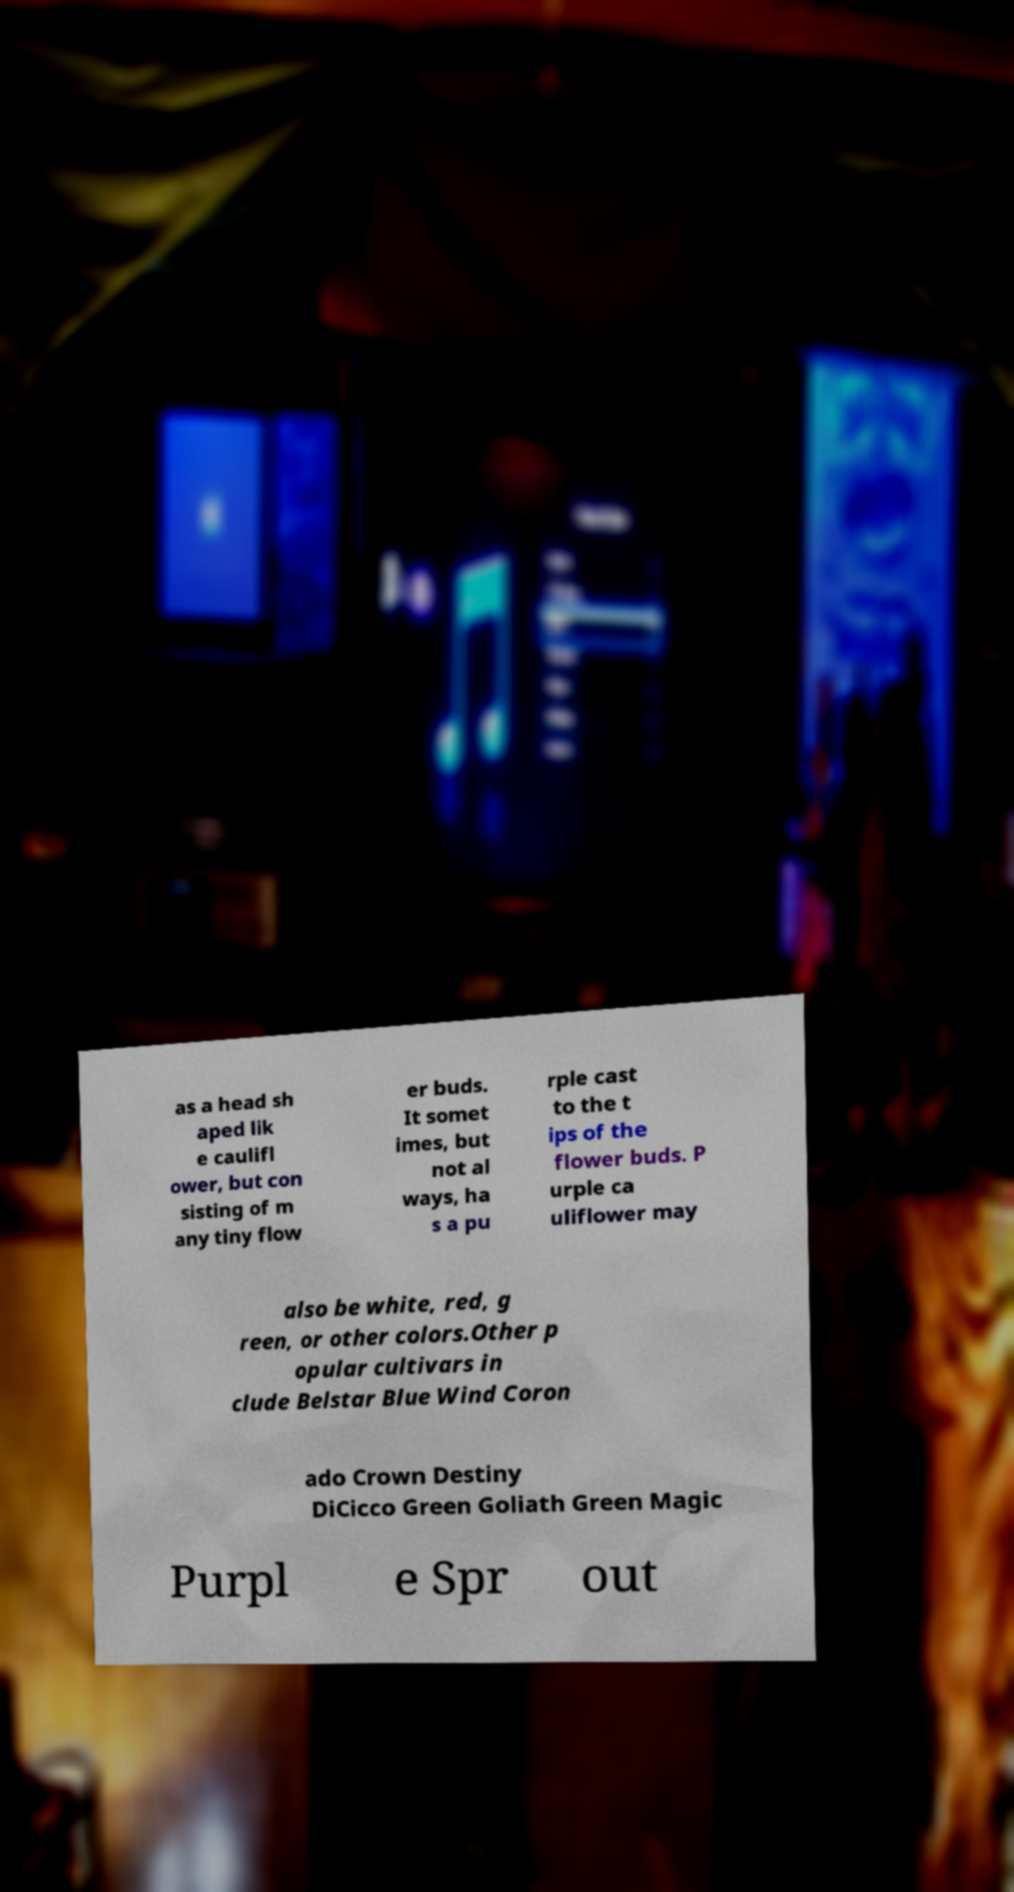For documentation purposes, I need the text within this image transcribed. Could you provide that? as a head sh aped lik e caulifl ower, but con sisting of m any tiny flow er buds. It somet imes, but not al ways, ha s a pu rple cast to the t ips of the flower buds. P urple ca uliflower may also be white, red, g reen, or other colors.Other p opular cultivars in clude Belstar Blue Wind Coron ado Crown Destiny DiCicco Green Goliath Green Magic Purpl e Spr out 